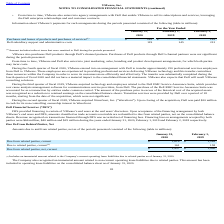According to Vmware's financial document, What did Purchases and leases of products and purchases of services include? indirect taxes that were remitted to Dell during the periods presented.. The document states: "(1) Amount includes indirect taxes that were remitted to Dell during the periods presented...." Also, Which years does the table provide information for VMware’s payments for such arrangements? The document contains multiple relevant values: 2020, 2019, 2018. From the document: "2020 2019 2018 2020 2019 2018 2020 2019 2018..." Also, What were the Dell subsidiary support and administrative costs in 2020? According to the financial document, 119 (in millions). The relevant text states: "Dell subsidiary support and administrative costs 119 145 212..." Also, can you calculate: What was the change in Purchases and leases of products and purchases of services between 2018 and 2019? Based on the calculation: 200-142, the result is 58 (in millions). This is based on the information: "ducts and purchases of services (1) $ 242 $ 200 $ 142 of products and purchases of services (1) $ 242 $ 200 $ 142..." The key data points involved are: 142, 200. Also, How many years did Dell subsidiary support and administrative costs exceed $150 million? Based on the analysis, there are 1 instances. The counting process: 2018. Also, can you calculate: What was the percentage change in Dell subsidiary support and administrative costs between 2019 and 2020? To answer this question, I need to perform calculations using the financial data. The calculation is: (119-145)/145, which equals -17.93 (percentage). This is based on the information: "l subsidiary support and administrative costs 119 145 212 Dell subsidiary support and administrative costs 119 145 212..." The key data points involved are: 119, 145. 